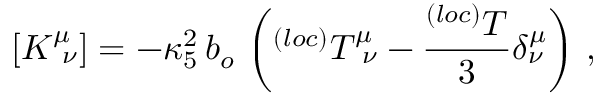Convert formula to latex. <formula><loc_0><loc_0><loc_500><loc_500>[ K _ { \nu } ^ { \mu } ] = - \kappa _ { 5 } ^ { 2 } \, b _ { o } \, \left ( ^ { ( l o c ) } T _ { \nu } ^ { \mu } - \frac { ^ { ( l o c ) } T } { 3 } \delta _ { \nu } ^ { \mu } \right ) \, ,</formula> 